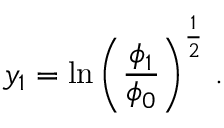<formula> <loc_0><loc_0><loc_500><loc_500>y _ { 1 } = \ln \left ( { { \frac { \phi _ { 1 } } { \phi _ { 0 } } } } \right ) ^ { \frac { 1 } { 2 } } \, .</formula> 